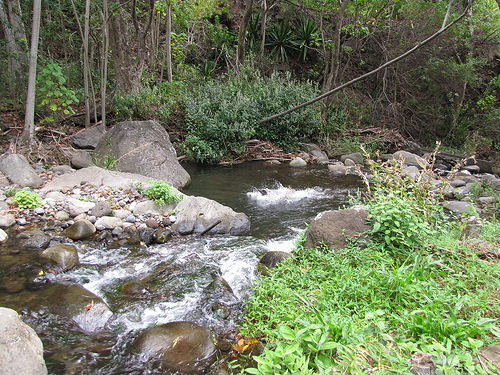<image>
Is the water behind the tree? No. The water is not behind the tree. From this viewpoint, the water appears to be positioned elsewhere in the scene. 